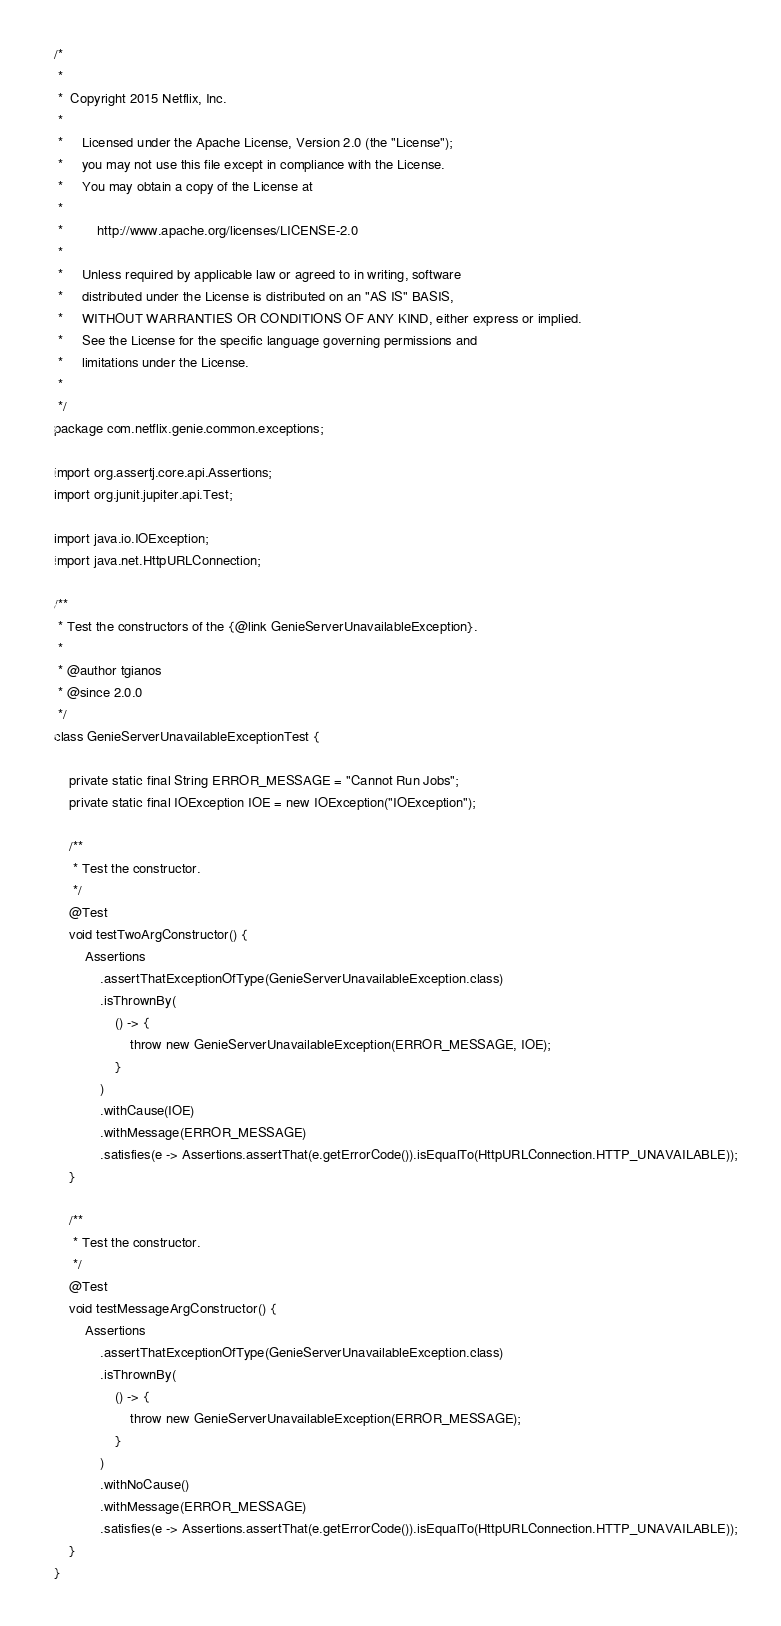<code> <loc_0><loc_0><loc_500><loc_500><_Java_>/*
 *
 *  Copyright 2015 Netflix, Inc.
 *
 *     Licensed under the Apache License, Version 2.0 (the "License");
 *     you may not use this file except in compliance with the License.
 *     You may obtain a copy of the License at
 *
 *         http://www.apache.org/licenses/LICENSE-2.0
 *
 *     Unless required by applicable law or agreed to in writing, software
 *     distributed under the License is distributed on an "AS IS" BASIS,
 *     WITHOUT WARRANTIES OR CONDITIONS OF ANY KIND, either express or implied.
 *     See the License for the specific language governing permissions and
 *     limitations under the License.
 *
 */
package com.netflix.genie.common.exceptions;

import org.assertj.core.api.Assertions;
import org.junit.jupiter.api.Test;

import java.io.IOException;
import java.net.HttpURLConnection;

/**
 * Test the constructors of the {@link GenieServerUnavailableException}.
 *
 * @author tgianos
 * @since 2.0.0
 */
class GenieServerUnavailableExceptionTest {

    private static final String ERROR_MESSAGE = "Cannot Run Jobs";
    private static final IOException IOE = new IOException("IOException");

    /**
     * Test the constructor.
     */
    @Test
    void testTwoArgConstructor() {
        Assertions
            .assertThatExceptionOfType(GenieServerUnavailableException.class)
            .isThrownBy(
                () -> {
                    throw new GenieServerUnavailableException(ERROR_MESSAGE, IOE);
                }
            )
            .withCause(IOE)
            .withMessage(ERROR_MESSAGE)
            .satisfies(e -> Assertions.assertThat(e.getErrorCode()).isEqualTo(HttpURLConnection.HTTP_UNAVAILABLE));
    }

    /**
     * Test the constructor.
     */
    @Test
    void testMessageArgConstructor() {
        Assertions
            .assertThatExceptionOfType(GenieServerUnavailableException.class)
            .isThrownBy(
                () -> {
                    throw new GenieServerUnavailableException(ERROR_MESSAGE);
                }
            )
            .withNoCause()
            .withMessage(ERROR_MESSAGE)
            .satisfies(e -> Assertions.assertThat(e.getErrorCode()).isEqualTo(HttpURLConnection.HTTP_UNAVAILABLE));
    }
}
</code> 